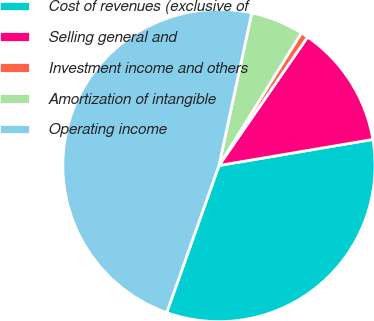<chart> <loc_0><loc_0><loc_500><loc_500><pie_chart><fcel>Cost of revenues (exclusive of<fcel>Selling general and<fcel>Investment income and others<fcel>Amortization of intangible<fcel>Operating income<nl><fcel>33.1%<fcel>12.72%<fcel>0.76%<fcel>5.48%<fcel>47.94%<nl></chart> 